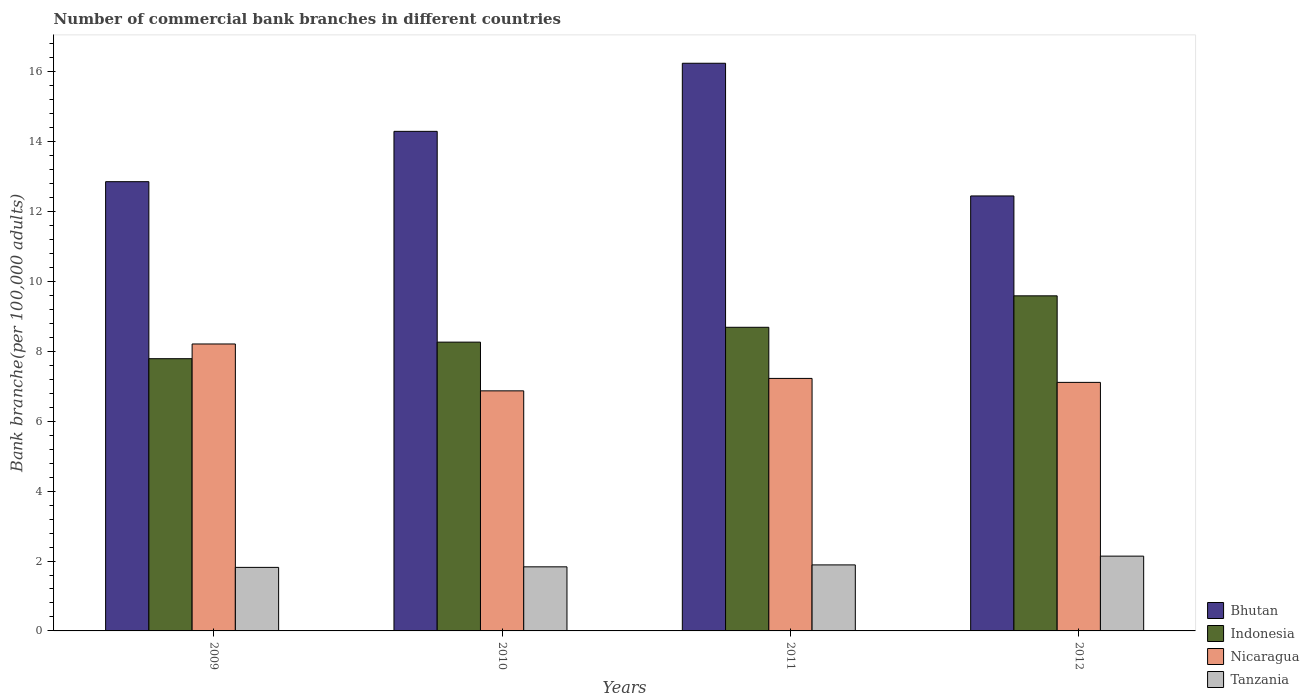How many different coloured bars are there?
Make the answer very short. 4. Are the number of bars per tick equal to the number of legend labels?
Offer a terse response. Yes. In how many cases, is the number of bars for a given year not equal to the number of legend labels?
Provide a short and direct response. 0. What is the number of commercial bank branches in Bhutan in 2012?
Your response must be concise. 12.45. Across all years, what is the maximum number of commercial bank branches in Nicaragua?
Provide a short and direct response. 8.21. Across all years, what is the minimum number of commercial bank branches in Nicaragua?
Keep it short and to the point. 6.87. What is the total number of commercial bank branches in Bhutan in the graph?
Make the answer very short. 55.85. What is the difference between the number of commercial bank branches in Nicaragua in 2010 and that in 2012?
Make the answer very short. -0.24. What is the difference between the number of commercial bank branches in Tanzania in 2010 and the number of commercial bank branches in Indonesia in 2009?
Make the answer very short. -5.96. What is the average number of commercial bank branches in Bhutan per year?
Offer a terse response. 13.96. In the year 2010, what is the difference between the number of commercial bank branches in Indonesia and number of commercial bank branches in Tanzania?
Give a very brief answer. 6.43. In how many years, is the number of commercial bank branches in Indonesia greater than 8.8?
Offer a very short reply. 1. What is the ratio of the number of commercial bank branches in Indonesia in 2009 to that in 2012?
Your answer should be very brief. 0.81. Is the difference between the number of commercial bank branches in Indonesia in 2009 and 2012 greater than the difference between the number of commercial bank branches in Tanzania in 2009 and 2012?
Ensure brevity in your answer.  No. What is the difference between the highest and the second highest number of commercial bank branches in Tanzania?
Your response must be concise. 0.25. What is the difference between the highest and the lowest number of commercial bank branches in Bhutan?
Offer a very short reply. 3.8. Is it the case that in every year, the sum of the number of commercial bank branches in Indonesia and number of commercial bank branches in Nicaragua is greater than the sum of number of commercial bank branches in Bhutan and number of commercial bank branches in Tanzania?
Offer a terse response. Yes. What does the 1st bar from the left in 2011 represents?
Offer a terse response. Bhutan. What does the 3rd bar from the right in 2009 represents?
Your answer should be very brief. Indonesia. Is it the case that in every year, the sum of the number of commercial bank branches in Tanzania and number of commercial bank branches in Indonesia is greater than the number of commercial bank branches in Bhutan?
Keep it short and to the point. No. What is the difference between two consecutive major ticks on the Y-axis?
Give a very brief answer. 2. Does the graph contain grids?
Keep it short and to the point. No. How many legend labels are there?
Your response must be concise. 4. How are the legend labels stacked?
Your answer should be compact. Vertical. What is the title of the graph?
Your response must be concise. Number of commercial bank branches in different countries. Does "Chad" appear as one of the legend labels in the graph?
Your answer should be compact. No. What is the label or title of the Y-axis?
Give a very brief answer. Bank branche(per 100,0 adults). What is the Bank branche(per 100,000 adults) of Bhutan in 2009?
Make the answer very short. 12.86. What is the Bank branche(per 100,000 adults) of Indonesia in 2009?
Keep it short and to the point. 7.79. What is the Bank branche(per 100,000 adults) of Nicaragua in 2009?
Provide a short and direct response. 8.21. What is the Bank branche(per 100,000 adults) in Tanzania in 2009?
Your answer should be very brief. 1.82. What is the Bank branche(per 100,000 adults) of Bhutan in 2010?
Give a very brief answer. 14.3. What is the Bank branche(per 100,000 adults) in Indonesia in 2010?
Ensure brevity in your answer.  8.27. What is the Bank branche(per 100,000 adults) of Nicaragua in 2010?
Give a very brief answer. 6.87. What is the Bank branche(per 100,000 adults) in Tanzania in 2010?
Ensure brevity in your answer.  1.83. What is the Bank branche(per 100,000 adults) in Bhutan in 2011?
Your answer should be compact. 16.25. What is the Bank branche(per 100,000 adults) in Indonesia in 2011?
Your answer should be compact. 8.69. What is the Bank branche(per 100,000 adults) in Nicaragua in 2011?
Provide a short and direct response. 7.23. What is the Bank branche(per 100,000 adults) in Tanzania in 2011?
Your answer should be compact. 1.89. What is the Bank branche(per 100,000 adults) in Bhutan in 2012?
Make the answer very short. 12.45. What is the Bank branche(per 100,000 adults) of Indonesia in 2012?
Provide a short and direct response. 9.59. What is the Bank branche(per 100,000 adults) of Nicaragua in 2012?
Provide a short and direct response. 7.11. What is the Bank branche(per 100,000 adults) of Tanzania in 2012?
Provide a short and direct response. 2.14. Across all years, what is the maximum Bank branche(per 100,000 adults) of Bhutan?
Provide a succinct answer. 16.25. Across all years, what is the maximum Bank branche(per 100,000 adults) of Indonesia?
Your answer should be compact. 9.59. Across all years, what is the maximum Bank branche(per 100,000 adults) of Nicaragua?
Provide a succinct answer. 8.21. Across all years, what is the maximum Bank branche(per 100,000 adults) in Tanzania?
Provide a succinct answer. 2.14. Across all years, what is the minimum Bank branche(per 100,000 adults) in Bhutan?
Ensure brevity in your answer.  12.45. Across all years, what is the minimum Bank branche(per 100,000 adults) of Indonesia?
Make the answer very short. 7.79. Across all years, what is the minimum Bank branche(per 100,000 adults) in Nicaragua?
Your answer should be very brief. 6.87. Across all years, what is the minimum Bank branche(per 100,000 adults) in Tanzania?
Offer a terse response. 1.82. What is the total Bank branche(per 100,000 adults) of Bhutan in the graph?
Provide a short and direct response. 55.85. What is the total Bank branche(per 100,000 adults) in Indonesia in the graph?
Make the answer very short. 34.34. What is the total Bank branche(per 100,000 adults) of Nicaragua in the graph?
Provide a succinct answer. 29.42. What is the total Bank branche(per 100,000 adults) in Tanzania in the graph?
Provide a succinct answer. 7.68. What is the difference between the Bank branche(per 100,000 adults) of Bhutan in 2009 and that in 2010?
Ensure brevity in your answer.  -1.44. What is the difference between the Bank branche(per 100,000 adults) of Indonesia in 2009 and that in 2010?
Your answer should be compact. -0.47. What is the difference between the Bank branche(per 100,000 adults) in Nicaragua in 2009 and that in 2010?
Offer a terse response. 1.34. What is the difference between the Bank branche(per 100,000 adults) in Tanzania in 2009 and that in 2010?
Keep it short and to the point. -0.02. What is the difference between the Bank branche(per 100,000 adults) in Bhutan in 2009 and that in 2011?
Your answer should be very brief. -3.39. What is the difference between the Bank branche(per 100,000 adults) of Indonesia in 2009 and that in 2011?
Make the answer very short. -0.9. What is the difference between the Bank branche(per 100,000 adults) of Nicaragua in 2009 and that in 2011?
Offer a terse response. 0.99. What is the difference between the Bank branche(per 100,000 adults) of Tanzania in 2009 and that in 2011?
Provide a short and direct response. -0.07. What is the difference between the Bank branche(per 100,000 adults) of Bhutan in 2009 and that in 2012?
Ensure brevity in your answer.  0.41. What is the difference between the Bank branche(per 100,000 adults) in Indonesia in 2009 and that in 2012?
Your answer should be compact. -1.8. What is the difference between the Bank branche(per 100,000 adults) of Nicaragua in 2009 and that in 2012?
Offer a very short reply. 1.1. What is the difference between the Bank branche(per 100,000 adults) in Tanzania in 2009 and that in 2012?
Keep it short and to the point. -0.32. What is the difference between the Bank branche(per 100,000 adults) in Bhutan in 2010 and that in 2011?
Your answer should be very brief. -1.95. What is the difference between the Bank branche(per 100,000 adults) in Indonesia in 2010 and that in 2011?
Your answer should be very brief. -0.42. What is the difference between the Bank branche(per 100,000 adults) in Nicaragua in 2010 and that in 2011?
Make the answer very short. -0.36. What is the difference between the Bank branche(per 100,000 adults) in Tanzania in 2010 and that in 2011?
Provide a succinct answer. -0.06. What is the difference between the Bank branche(per 100,000 adults) of Bhutan in 2010 and that in 2012?
Your answer should be very brief. 1.85. What is the difference between the Bank branche(per 100,000 adults) of Indonesia in 2010 and that in 2012?
Make the answer very short. -1.33. What is the difference between the Bank branche(per 100,000 adults) in Nicaragua in 2010 and that in 2012?
Keep it short and to the point. -0.24. What is the difference between the Bank branche(per 100,000 adults) in Tanzania in 2010 and that in 2012?
Your answer should be compact. -0.31. What is the difference between the Bank branche(per 100,000 adults) of Bhutan in 2011 and that in 2012?
Your answer should be compact. 3.8. What is the difference between the Bank branche(per 100,000 adults) in Indonesia in 2011 and that in 2012?
Your answer should be compact. -0.9. What is the difference between the Bank branche(per 100,000 adults) in Nicaragua in 2011 and that in 2012?
Offer a very short reply. 0.11. What is the difference between the Bank branche(per 100,000 adults) of Tanzania in 2011 and that in 2012?
Keep it short and to the point. -0.25. What is the difference between the Bank branche(per 100,000 adults) in Bhutan in 2009 and the Bank branche(per 100,000 adults) in Indonesia in 2010?
Make the answer very short. 4.59. What is the difference between the Bank branche(per 100,000 adults) of Bhutan in 2009 and the Bank branche(per 100,000 adults) of Nicaragua in 2010?
Provide a succinct answer. 5.99. What is the difference between the Bank branche(per 100,000 adults) in Bhutan in 2009 and the Bank branche(per 100,000 adults) in Tanzania in 2010?
Give a very brief answer. 11.02. What is the difference between the Bank branche(per 100,000 adults) in Indonesia in 2009 and the Bank branche(per 100,000 adults) in Nicaragua in 2010?
Give a very brief answer. 0.92. What is the difference between the Bank branche(per 100,000 adults) in Indonesia in 2009 and the Bank branche(per 100,000 adults) in Tanzania in 2010?
Provide a succinct answer. 5.96. What is the difference between the Bank branche(per 100,000 adults) of Nicaragua in 2009 and the Bank branche(per 100,000 adults) of Tanzania in 2010?
Ensure brevity in your answer.  6.38. What is the difference between the Bank branche(per 100,000 adults) of Bhutan in 2009 and the Bank branche(per 100,000 adults) of Indonesia in 2011?
Offer a very short reply. 4.17. What is the difference between the Bank branche(per 100,000 adults) in Bhutan in 2009 and the Bank branche(per 100,000 adults) in Nicaragua in 2011?
Keep it short and to the point. 5.63. What is the difference between the Bank branche(per 100,000 adults) of Bhutan in 2009 and the Bank branche(per 100,000 adults) of Tanzania in 2011?
Keep it short and to the point. 10.97. What is the difference between the Bank branche(per 100,000 adults) of Indonesia in 2009 and the Bank branche(per 100,000 adults) of Nicaragua in 2011?
Provide a short and direct response. 0.56. What is the difference between the Bank branche(per 100,000 adults) in Indonesia in 2009 and the Bank branche(per 100,000 adults) in Tanzania in 2011?
Keep it short and to the point. 5.9. What is the difference between the Bank branche(per 100,000 adults) in Nicaragua in 2009 and the Bank branche(per 100,000 adults) in Tanzania in 2011?
Your answer should be compact. 6.32. What is the difference between the Bank branche(per 100,000 adults) in Bhutan in 2009 and the Bank branche(per 100,000 adults) in Indonesia in 2012?
Give a very brief answer. 3.27. What is the difference between the Bank branche(per 100,000 adults) of Bhutan in 2009 and the Bank branche(per 100,000 adults) of Nicaragua in 2012?
Provide a short and direct response. 5.74. What is the difference between the Bank branche(per 100,000 adults) in Bhutan in 2009 and the Bank branche(per 100,000 adults) in Tanzania in 2012?
Provide a short and direct response. 10.72. What is the difference between the Bank branche(per 100,000 adults) in Indonesia in 2009 and the Bank branche(per 100,000 adults) in Nicaragua in 2012?
Provide a succinct answer. 0.68. What is the difference between the Bank branche(per 100,000 adults) of Indonesia in 2009 and the Bank branche(per 100,000 adults) of Tanzania in 2012?
Your answer should be compact. 5.65. What is the difference between the Bank branche(per 100,000 adults) of Nicaragua in 2009 and the Bank branche(per 100,000 adults) of Tanzania in 2012?
Your answer should be very brief. 6.07. What is the difference between the Bank branche(per 100,000 adults) of Bhutan in 2010 and the Bank branche(per 100,000 adults) of Indonesia in 2011?
Your answer should be compact. 5.61. What is the difference between the Bank branche(per 100,000 adults) in Bhutan in 2010 and the Bank branche(per 100,000 adults) in Nicaragua in 2011?
Your response must be concise. 7.07. What is the difference between the Bank branche(per 100,000 adults) in Bhutan in 2010 and the Bank branche(per 100,000 adults) in Tanzania in 2011?
Your response must be concise. 12.41. What is the difference between the Bank branche(per 100,000 adults) in Indonesia in 2010 and the Bank branche(per 100,000 adults) in Nicaragua in 2011?
Keep it short and to the point. 1.04. What is the difference between the Bank branche(per 100,000 adults) in Indonesia in 2010 and the Bank branche(per 100,000 adults) in Tanzania in 2011?
Your answer should be very brief. 6.38. What is the difference between the Bank branche(per 100,000 adults) of Nicaragua in 2010 and the Bank branche(per 100,000 adults) of Tanzania in 2011?
Make the answer very short. 4.98. What is the difference between the Bank branche(per 100,000 adults) in Bhutan in 2010 and the Bank branche(per 100,000 adults) in Indonesia in 2012?
Make the answer very short. 4.71. What is the difference between the Bank branche(per 100,000 adults) in Bhutan in 2010 and the Bank branche(per 100,000 adults) in Nicaragua in 2012?
Provide a succinct answer. 7.18. What is the difference between the Bank branche(per 100,000 adults) of Bhutan in 2010 and the Bank branche(per 100,000 adults) of Tanzania in 2012?
Ensure brevity in your answer.  12.16. What is the difference between the Bank branche(per 100,000 adults) of Indonesia in 2010 and the Bank branche(per 100,000 adults) of Nicaragua in 2012?
Ensure brevity in your answer.  1.15. What is the difference between the Bank branche(per 100,000 adults) of Indonesia in 2010 and the Bank branche(per 100,000 adults) of Tanzania in 2012?
Provide a short and direct response. 6.13. What is the difference between the Bank branche(per 100,000 adults) in Nicaragua in 2010 and the Bank branche(per 100,000 adults) in Tanzania in 2012?
Offer a very short reply. 4.73. What is the difference between the Bank branche(per 100,000 adults) of Bhutan in 2011 and the Bank branche(per 100,000 adults) of Indonesia in 2012?
Make the answer very short. 6.66. What is the difference between the Bank branche(per 100,000 adults) in Bhutan in 2011 and the Bank branche(per 100,000 adults) in Nicaragua in 2012?
Your answer should be very brief. 9.13. What is the difference between the Bank branche(per 100,000 adults) in Bhutan in 2011 and the Bank branche(per 100,000 adults) in Tanzania in 2012?
Keep it short and to the point. 14.11. What is the difference between the Bank branche(per 100,000 adults) in Indonesia in 2011 and the Bank branche(per 100,000 adults) in Nicaragua in 2012?
Offer a terse response. 1.58. What is the difference between the Bank branche(per 100,000 adults) of Indonesia in 2011 and the Bank branche(per 100,000 adults) of Tanzania in 2012?
Ensure brevity in your answer.  6.55. What is the difference between the Bank branche(per 100,000 adults) of Nicaragua in 2011 and the Bank branche(per 100,000 adults) of Tanzania in 2012?
Make the answer very short. 5.09. What is the average Bank branche(per 100,000 adults) in Bhutan per year?
Offer a very short reply. 13.96. What is the average Bank branche(per 100,000 adults) in Indonesia per year?
Offer a very short reply. 8.58. What is the average Bank branche(per 100,000 adults) of Nicaragua per year?
Offer a terse response. 7.36. What is the average Bank branche(per 100,000 adults) of Tanzania per year?
Provide a short and direct response. 1.92. In the year 2009, what is the difference between the Bank branche(per 100,000 adults) in Bhutan and Bank branche(per 100,000 adults) in Indonesia?
Make the answer very short. 5.07. In the year 2009, what is the difference between the Bank branche(per 100,000 adults) of Bhutan and Bank branche(per 100,000 adults) of Nicaragua?
Provide a succinct answer. 4.64. In the year 2009, what is the difference between the Bank branche(per 100,000 adults) in Bhutan and Bank branche(per 100,000 adults) in Tanzania?
Offer a very short reply. 11.04. In the year 2009, what is the difference between the Bank branche(per 100,000 adults) of Indonesia and Bank branche(per 100,000 adults) of Nicaragua?
Keep it short and to the point. -0.42. In the year 2009, what is the difference between the Bank branche(per 100,000 adults) in Indonesia and Bank branche(per 100,000 adults) in Tanzania?
Provide a short and direct response. 5.97. In the year 2009, what is the difference between the Bank branche(per 100,000 adults) in Nicaragua and Bank branche(per 100,000 adults) in Tanzania?
Provide a succinct answer. 6.39. In the year 2010, what is the difference between the Bank branche(per 100,000 adults) in Bhutan and Bank branche(per 100,000 adults) in Indonesia?
Provide a short and direct response. 6.03. In the year 2010, what is the difference between the Bank branche(per 100,000 adults) in Bhutan and Bank branche(per 100,000 adults) in Nicaragua?
Your answer should be very brief. 7.43. In the year 2010, what is the difference between the Bank branche(per 100,000 adults) of Bhutan and Bank branche(per 100,000 adults) of Tanzania?
Your answer should be very brief. 12.46. In the year 2010, what is the difference between the Bank branche(per 100,000 adults) of Indonesia and Bank branche(per 100,000 adults) of Nicaragua?
Provide a short and direct response. 1.39. In the year 2010, what is the difference between the Bank branche(per 100,000 adults) in Indonesia and Bank branche(per 100,000 adults) in Tanzania?
Offer a very short reply. 6.43. In the year 2010, what is the difference between the Bank branche(per 100,000 adults) of Nicaragua and Bank branche(per 100,000 adults) of Tanzania?
Your response must be concise. 5.04. In the year 2011, what is the difference between the Bank branche(per 100,000 adults) in Bhutan and Bank branche(per 100,000 adults) in Indonesia?
Your answer should be very brief. 7.56. In the year 2011, what is the difference between the Bank branche(per 100,000 adults) of Bhutan and Bank branche(per 100,000 adults) of Nicaragua?
Your answer should be compact. 9.02. In the year 2011, what is the difference between the Bank branche(per 100,000 adults) in Bhutan and Bank branche(per 100,000 adults) in Tanzania?
Your answer should be compact. 14.36. In the year 2011, what is the difference between the Bank branche(per 100,000 adults) of Indonesia and Bank branche(per 100,000 adults) of Nicaragua?
Give a very brief answer. 1.46. In the year 2011, what is the difference between the Bank branche(per 100,000 adults) in Indonesia and Bank branche(per 100,000 adults) in Tanzania?
Ensure brevity in your answer.  6.8. In the year 2011, what is the difference between the Bank branche(per 100,000 adults) of Nicaragua and Bank branche(per 100,000 adults) of Tanzania?
Offer a terse response. 5.34. In the year 2012, what is the difference between the Bank branche(per 100,000 adults) in Bhutan and Bank branche(per 100,000 adults) in Indonesia?
Keep it short and to the point. 2.86. In the year 2012, what is the difference between the Bank branche(per 100,000 adults) in Bhutan and Bank branche(per 100,000 adults) in Nicaragua?
Provide a succinct answer. 5.34. In the year 2012, what is the difference between the Bank branche(per 100,000 adults) in Bhutan and Bank branche(per 100,000 adults) in Tanzania?
Your answer should be very brief. 10.31. In the year 2012, what is the difference between the Bank branche(per 100,000 adults) in Indonesia and Bank branche(per 100,000 adults) in Nicaragua?
Provide a succinct answer. 2.48. In the year 2012, what is the difference between the Bank branche(per 100,000 adults) of Indonesia and Bank branche(per 100,000 adults) of Tanzania?
Give a very brief answer. 7.45. In the year 2012, what is the difference between the Bank branche(per 100,000 adults) of Nicaragua and Bank branche(per 100,000 adults) of Tanzania?
Your answer should be compact. 4.97. What is the ratio of the Bank branche(per 100,000 adults) of Bhutan in 2009 to that in 2010?
Your answer should be very brief. 0.9. What is the ratio of the Bank branche(per 100,000 adults) in Indonesia in 2009 to that in 2010?
Offer a very short reply. 0.94. What is the ratio of the Bank branche(per 100,000 adults) in Nicaragua in 2009 to that in 2010?
Offer a terse response. 1.2. What is the ratio of the Bank branche(per 100,000 adults) in Bhutan in 2009 to that in 2011?
Offer a very short reply. 0.79. What is the ratio of the Bank branche(per 100,000 adults) of Indonesia in 2009 to that in 2011?
Your answer should be very brief. 0.9. What is the ratio of the Bank branche(per 100,000 adults) of Nicaragua in 2009 to that in 2011?
Provide a short and direct response. 1.14. What is the ratio of the Bank branche(per 100,000 adults) in Tanzania in 2009 to that in 2011?
Provide a succinct answer. 0.96. What is the ratio of the Bank branche(per 100,000 adults) in Bhutan in 2009 to that in 2012?
Provide a succinct answer. 1.03. What is the ratio of the Bank branche(per 100,000 adults) of Indonesia in 2009 to that in 2012?
Offer a terse response. 0.81. What is the ratio of the Bank branche(per 100,000 adults) of Nicaragua in 2009 to that in 2012?
Keep it short and to the point. 1.15. What is the ratio of the Bank branche(per 100,000 adults) of Tanzania in 2009 to that in 2012?
Provide a succinct answer. 0.85. What is the ratio of the Bank branche(per 100,000 adults) of Indonesia in 2010 to that in 2011?
Keep it short and to the point. 0.95. What is the ratio of the Bank branche(per 100,000 adults) in Nicaragua in 2010 to that in 2011?
Your response must be concise. 0.95. What is the ratio of the Bank branche(per 100,000 adults) of Tanzania in 2010 to that in 2011?
Offer a terse response. 0.97. What is the ratio of the Bank branche(per 100,000 adults) in Bhutan in 2010 to that in 2012?
Keep it short and to the point. 1.15. What is the ratio of the Bank branche(per 100,000 adults) of Indonesia in 2010 to that in 2012?
Offer a terse response. 0.86. What is the ratio of the Bank branche(per 100,000 adults) of Nicaragua in 2010 to that in 2012?
Ensure brevity in your answer.  0.97. What is the ratio of the Bank branche(per 100,000 adults) in Tanzania in 2010 to that in 2012?
Provide a succinct answer. 0.86. What is the ratio of the Bank branche(per 100,000 adults) in Bhutan in 2011 to that in 2012?
Provide a succinct answer. 1.3. What is the ratio of the Bank branche(per 100,000 adults) of Indonesia in 2011 to that in 2012?
Offer a terse response. 0.91. What is the ratio of the Bank branche(per 100,000 adults) in Nicaragua in 2011 to that in 2012?
Your response must be concise. 1.02. What is the ratio of the Bank branche(per 100,000 adults) in Tanzania in 2011 to that in 2012?
Ensure brevity in your answer.  0.88. What is the difference between the highest and the second highest Bank branche(per 100,000 adults) of Bhutan?
Offer a very short reply. 1.95. What is the difference between the highest and the second highest Bank branche(per 100,000 adults) of Indonesia?
Give a very brief answer. 0.9. What is the difference between the highest and the second highest Bank branche(per 100,000 adults) of Nicaragua?
Provide a succinct answer. 0.99. What is the difference between the highest and the second highest Bank branche(per 100,000 adults) of Tanzania?
Offer a terse response. 0.25. What is the difference between the highest and the lowest Bank branche(per 100,000 adults) in Bhutan?
Keep it short and to the point. 3.8. What is the difference between the highest and the lowest Bank branche(per 100,000 adults) of Indonesia?
Provide a short and direct response. 1.8. What is the difference between the highest and the lowest Bank branche(per 100,000 adults) in Nicaragua?
Offer a terse response. 1.34. What is the difference between the highest and the lowest Bank branche(per 100,000 adults) in Tanzania?
Provide a succinct answer. 0.32. 